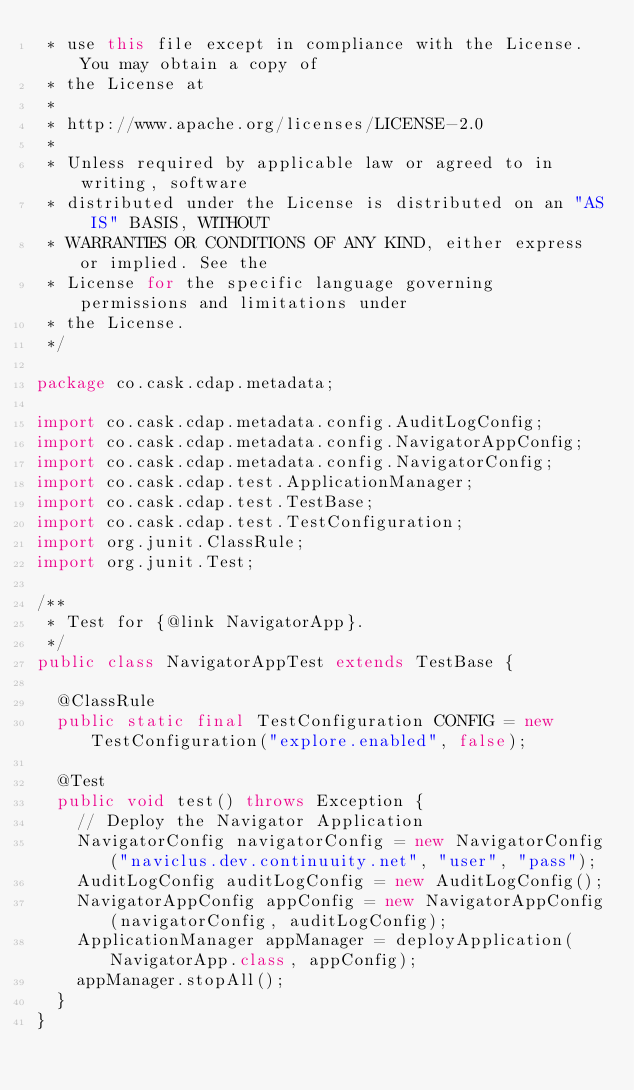Convert code to text. <code><loc_0><loc_0><loc_500><loc_500><_Java_> * use this file except in compliance with the License. You may obtain a copy of
 * the License at
 *
 * http://www.apache.org/licenses/LICENSE-2.0
 *
 * Unless required by applicable law or agreed to in writing, software
 * distributed under the License is distributed on an "AS IS" BASIS, WITHOUT
 * WARRANTIES OR CONDITIONS OF ANY KIND, either express or implied. See the
 * License for the specific language governing permissions and limitations under
 * the License.
 */

package co.cask.cdap.metadata;

import co.cask.cdap.metadata.config.AuditLogConfig;
import co.cask.cdap.metadata.config.NavigatorAppConfig;
import co.cask.cdap.metadata.config.NavigatorConfig;
import co.cask.cdap.test.ApplicationManager;
import co.cask.cdap.test.TestBase;
import co.cask.cdap.test.TestConfiguration;
import org.junit.ClassRule;
import org.junit.Test;

/**
 * Test for {@link NavigatorApp}.
 */
public class NavigatorAppTest extends TestBase {

  @ClassRule
  public static final TestConfiguration CONFIG = new TestConfiguration("explore.enabled", false);

  @Test
  public void test() throws Exception {
    // Deploy the Navigator Application
    NavigatorConfig navigatorConfig = new NavigatorConfig("naviclus.dev.continuuity.net", "user", "pass");
    AuditLogConfig auditLogConfig = new AuditLogConfig();
    NavigatorAppConfig appConfig = new NavigatorAppConfig(navigatorConfig, auditLogConfig);
    ApplicationManager appManager = deployApplication(NavigatorApp.class, appConfig);
    appManager.stopAll();
  }
}
</code> 